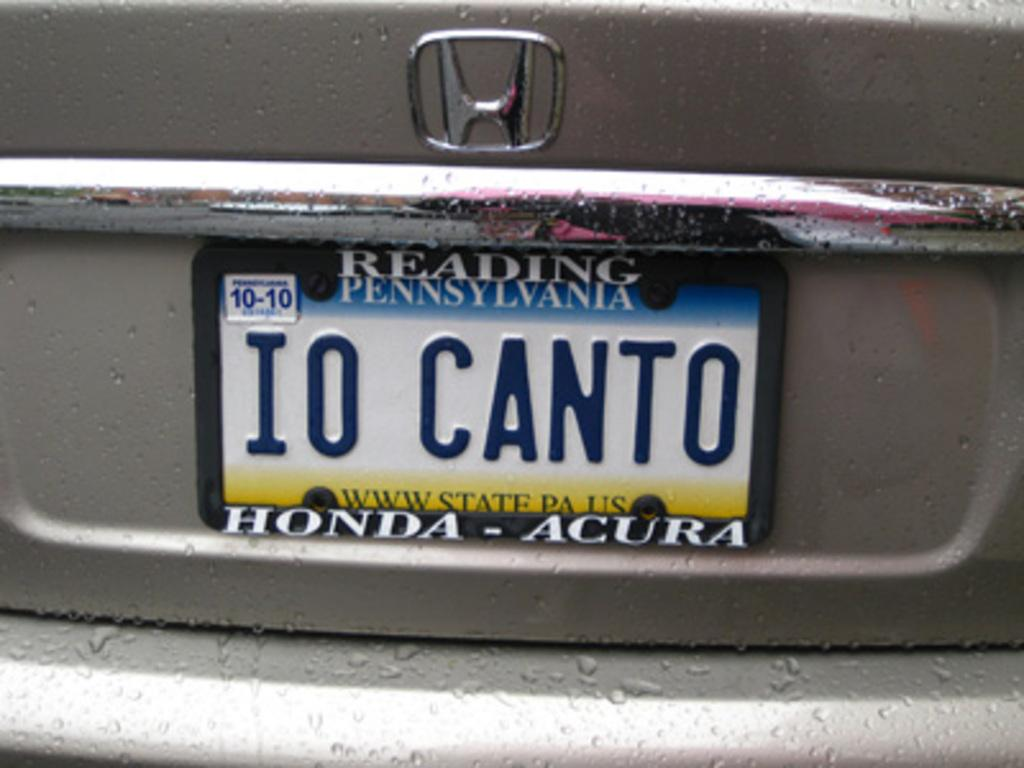<image>
Write a terse but informative summary of the picture. The license plate on the car is from the state of Pennsylvania 